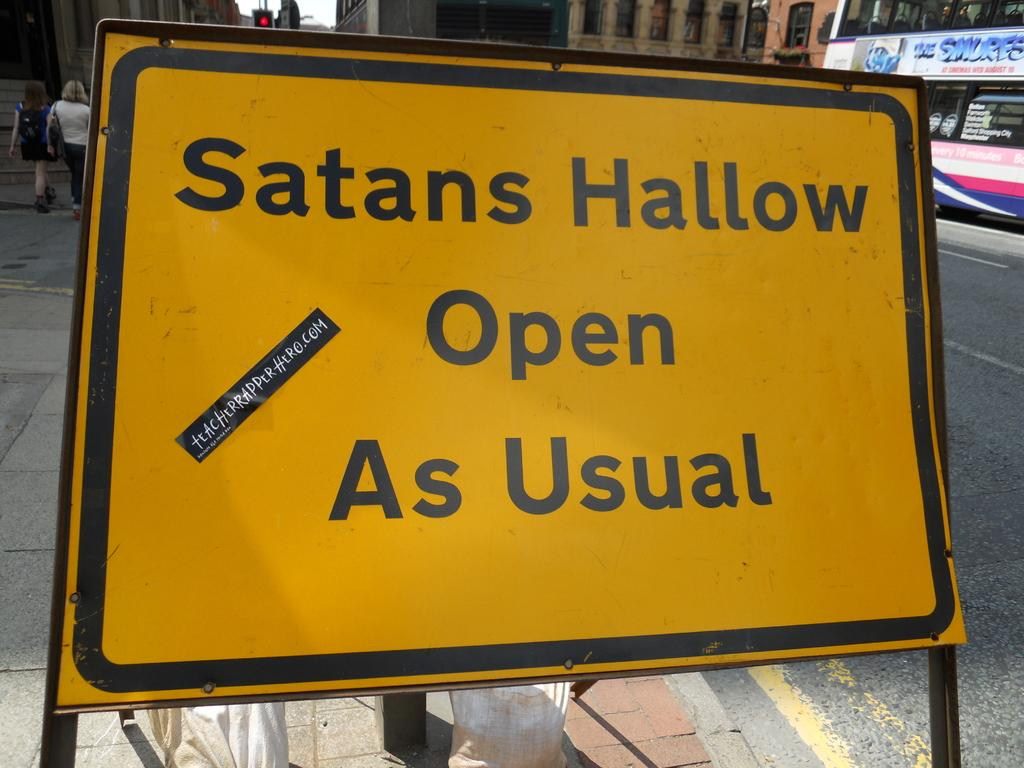<image>
Render a clear and concise summary of the photo. Yellow sign which says "Satans Hallow Open As Usual". 